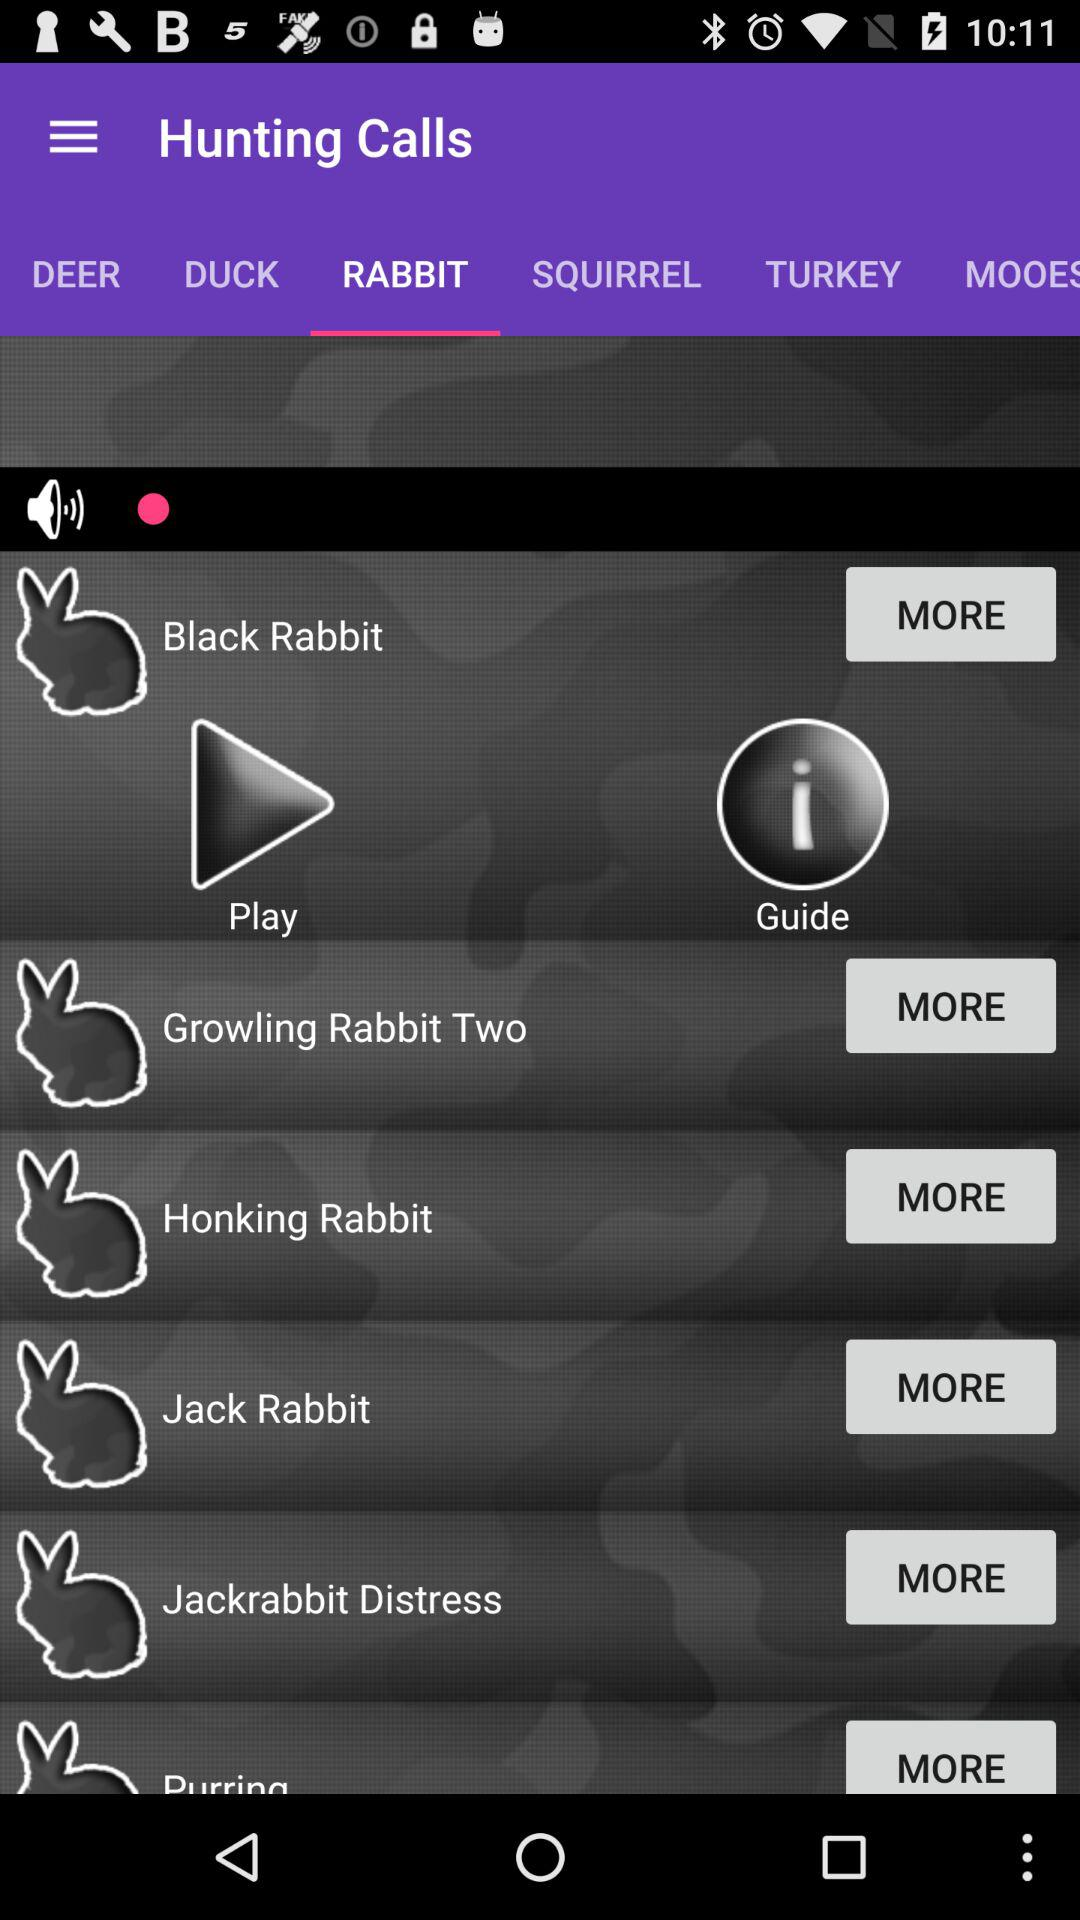Which tab is selected? The selected tab is "RABBIT". 